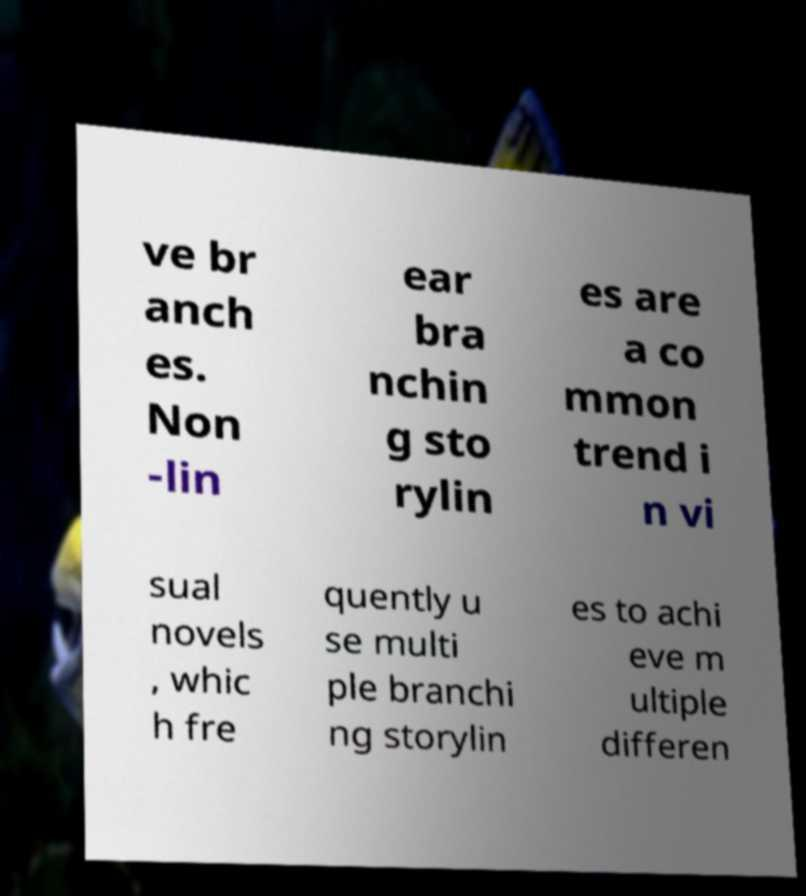Could you assist in decoding the text presented in this image and type it out clearly? ve br anch es. Non -lin ear bra nchin g sto rylin es are a co mmon trend i n vi sual novels , whic h fre quently u se multi ple branchi ng storylin es to achi eve m ultiple differen 